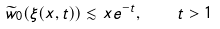Convert formula to latex. <formula><loc_0><loc_0><loc_500><loc_500>\widetilde { w } _ { 0 } ( \xi ( x , t ) ) \lesssim x e ^ { - t } , \quad t > 1</formula> 